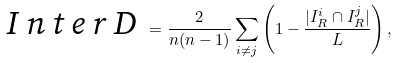Convert formula to latex. <formula><loc_0><loc_0><loc_500><loc_500>\emph { I n t e r D } = \frac { 2 } { n ( n - 1 ) } \sum _ { i \neq j } \left ( 1 - \frac { | I ^ { i } _ { R } \cap I ^ { j } _ { R } | } { L } \right ) ,</formula> 